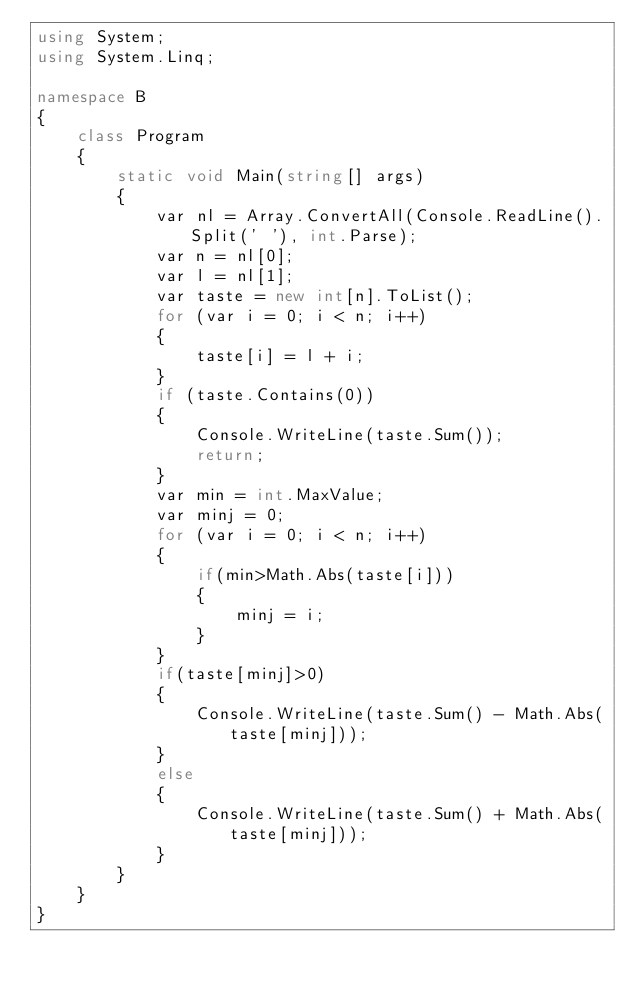Convert code to text. <code><loc_0><loc_0><loc_500><loc_500><_C#_>using System;
using System.Linq;

namespace B
{
    class Program
    {
        static void Main(string[] args)
        {
            var nl = Array.ConvertAll(Console.ReadLine().Split(' '), int.Parse);
            var n = nl[0];
            var l = nl[1];
            var taste = new int[n].ToList();
            for (var i = 0; i < n; i++)
            {
                taste[i] = l + i;
            }
            if (taste.Contains(0))
            {
                Console.WriteLine(taste.Sum());
                return;
            }
            var min = int.MaxValue;
            var minj = 0;
            for (var i = 0; i < n; i++)
            {
                if(min>Math.Abs(taste[i]))
                {
                    minj = i;
                }
            }
            if(taste[minj]>0)
            {
                Console.WriteLine(taste.Sum() - Math.Abs(taste[minj]));
            }
            else
            {
                Console.WriteLine(taste.Sum() + Math.Abs(taste[minj]));
            }
        }
    }
}
</code> 